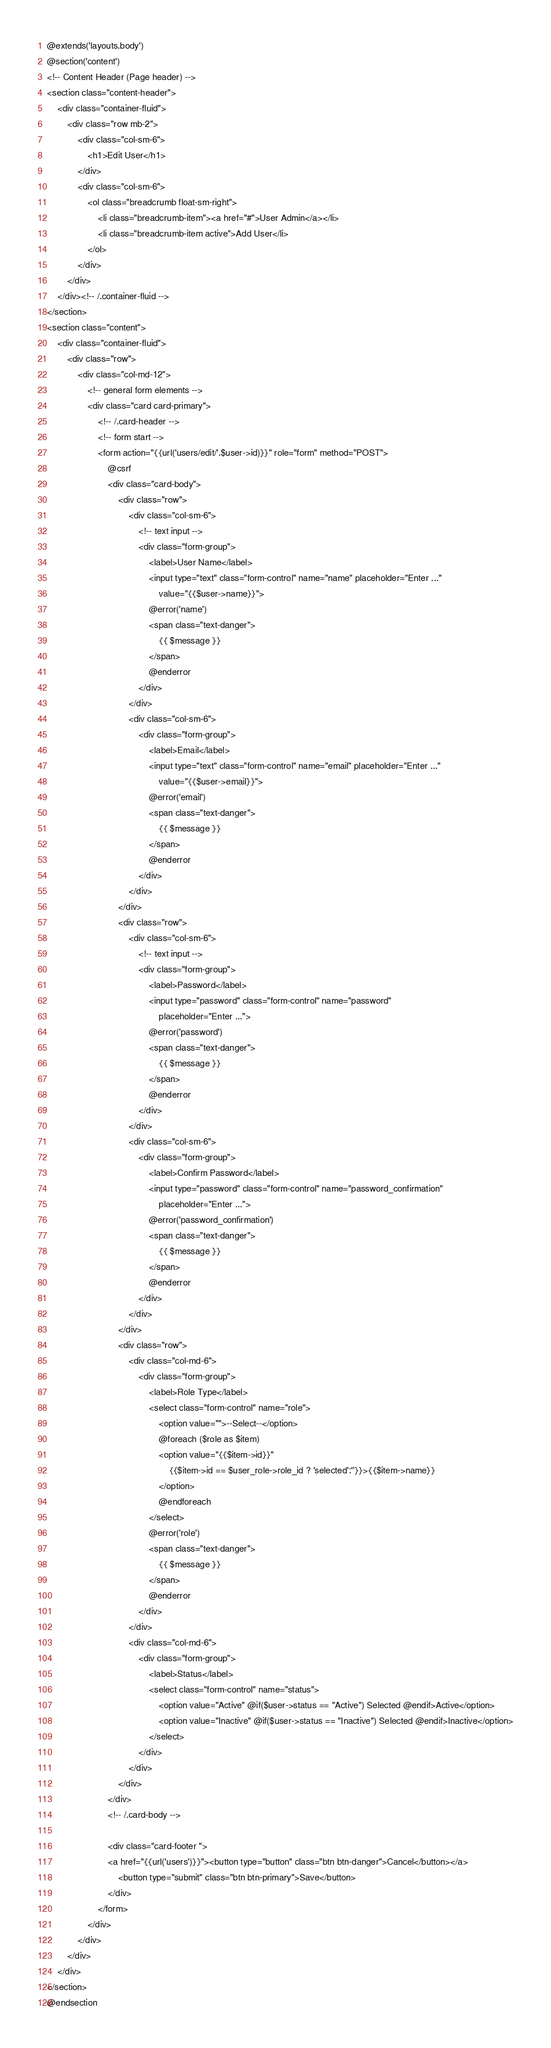Convert code to text. <code><loc_0><loc_0><loc_500><loc_500><_PHP_>@extends('layouts.body')
@section('content')
<!-- Content Header (Page header) -->
<section class="content-header">
    <div class="container-fluid">
        <div class="row mb-2">
            <div class="col-sm-6">
                <h1>Edit User</h1>
            </div>
            <div class="col-sm-6">
                <ol class="breadcrumb float-sm-right">
                    <li class="breadcrumb-item"><a href="#">User Admin</a></li>
                    <li class="breadcrumb-item active">Add User</li>
                </ol>
            </div>
        </div>
    </div><!-- /.container-fluid -->
</section>
<section class="content">
    <div class="container-fluid">
        <div class="row">
            <div class="col-md-12">
                <!-- general form elements -->
                <div class="card card-primary">
                    <!-- /.card-header -->
                    <!-- form start -->
                    <form action="{{url('users/edit/'.$user->id)}}" role="form" method="POST">
                        @csrf
                        <div class="card-body">
                            <div class="row">
                                <div class="col-sm-6">
                                    <!-- text input -->
                                    <div class="form-group">
                                        <label>User Name</label>
                                        <input type="text" class="form-control" name="name" placeholder="Enter ..."
                                            value="{{$user->name}}">
                                        @error('name')
                                        <span class="text-danger">
                                            {{ $message }}
                                        </span>
                                        @enderror
                                    </div>
                                </div>
                                <div class="col-sm-6">
                                    <div class="form-group">
                                        <label>Email</label>
                                        <input type="text" class="form-control" name="email" placeholder="Enter ..."
                                            value="{{$user->email}}">
                                        @error('email')
                                        <span class="text-danger">
                                            {{ $message }}
                                        </span>
                                        @enderror
                                    </div>
                                </div>
                            </div>
                            <div class="row">
                                <div class="col-sm-6">
                                    <!-- text input -->
                                    <div class="form-group">
                                        <label>Password</label>
                                        <input type="password" class="form-control" name="password"
                                            placeholder="Enter ...">
                                        @error('password')
                                        <span class="text-danger">
                                            {{ $message }}
                                        </span>
                                        @enderror
                                    </div>
                                </div>
                                <div class="col-sm-6">
                                    <div class="form-group">
                                        <label>Confirm Password</label>
                                        <input type="password" class="form-control" name="password_confirmation"
                                            placeholder="Enter ...">
                                        @error('password_confirmation')
                                        <span class="text-danger">
                                            {{ $message }}
                                        </span>
                                        @enderror
                                    </div>
                                </div>
                            </div>
                            <div class="row">
                                <div class="col-md-6">
                                    <div class="form-group">
                                        <label>Role Type</label>
                                        <select class="form-control" name="role">
                                            <option value="">--Select--</option>
                                            @foreach ($role as $item)
                                            <option value="{{$item->id}}"
                                                {{$item->id == $user_role->role_id ? 'selected':''}}>{{$item->name}}
                                            </option>
                                            @endforeach
                                        </select>
                                        @error('role')
                                        <span class="text-danger">
                                            {{ $message }}
                                        </span>
                                        @enderror
                                    </div>
                                </div>
                                <div class="col-md-6">
                                    <div class="form-group">
                                        <label>Status</label>
                                        <select class="form-control" name="status">
                                            <option value="Active" @if($user->status == "Active") Selected @endif>Active</option>
                                            <option value="Inactive" @if($user->status == "Inactive") Selected @endif>Inactive</option>
                                        </select>
                                    </div>
                                </div>
                            </div>
                        </div>
                        <!-- /.card-body -->

                        <div class="card-footer ">
                        <a href="{{url('users')}}"><button type="button" class="btn btn-danger">Cancel</button></a>
                            <button type="submit" class="btn btn-primary">Save</button>
                        </div>
                    </form>
                </div>
            </div>
        </div>
    </div>
</section>
@endsection</code> 